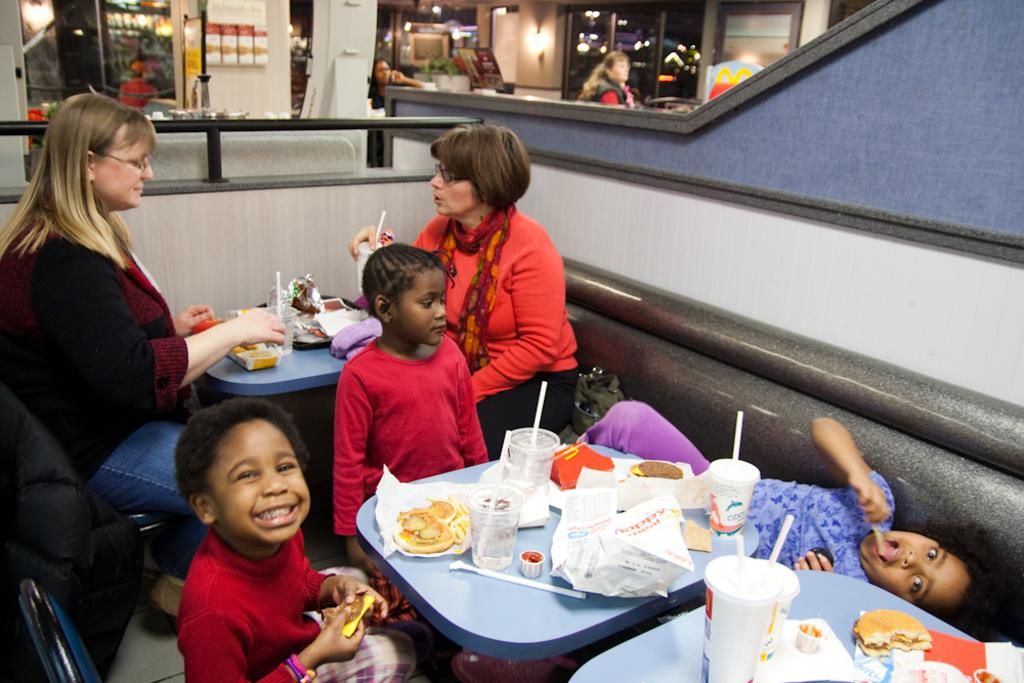What are the people in the image doing? There are persons sitting on chairs in the image. What is on the table in the image? There is a table in the image with glasses and food on it. Can you describe the woman in the background of the image? There is a woman in the background of the image, but no specific details are provided. What is the source of light in the background of the image? There is light in the background of the image, but the source is not specified. How many pies are on the truck in the image? There is no truck or pie present in the image. 